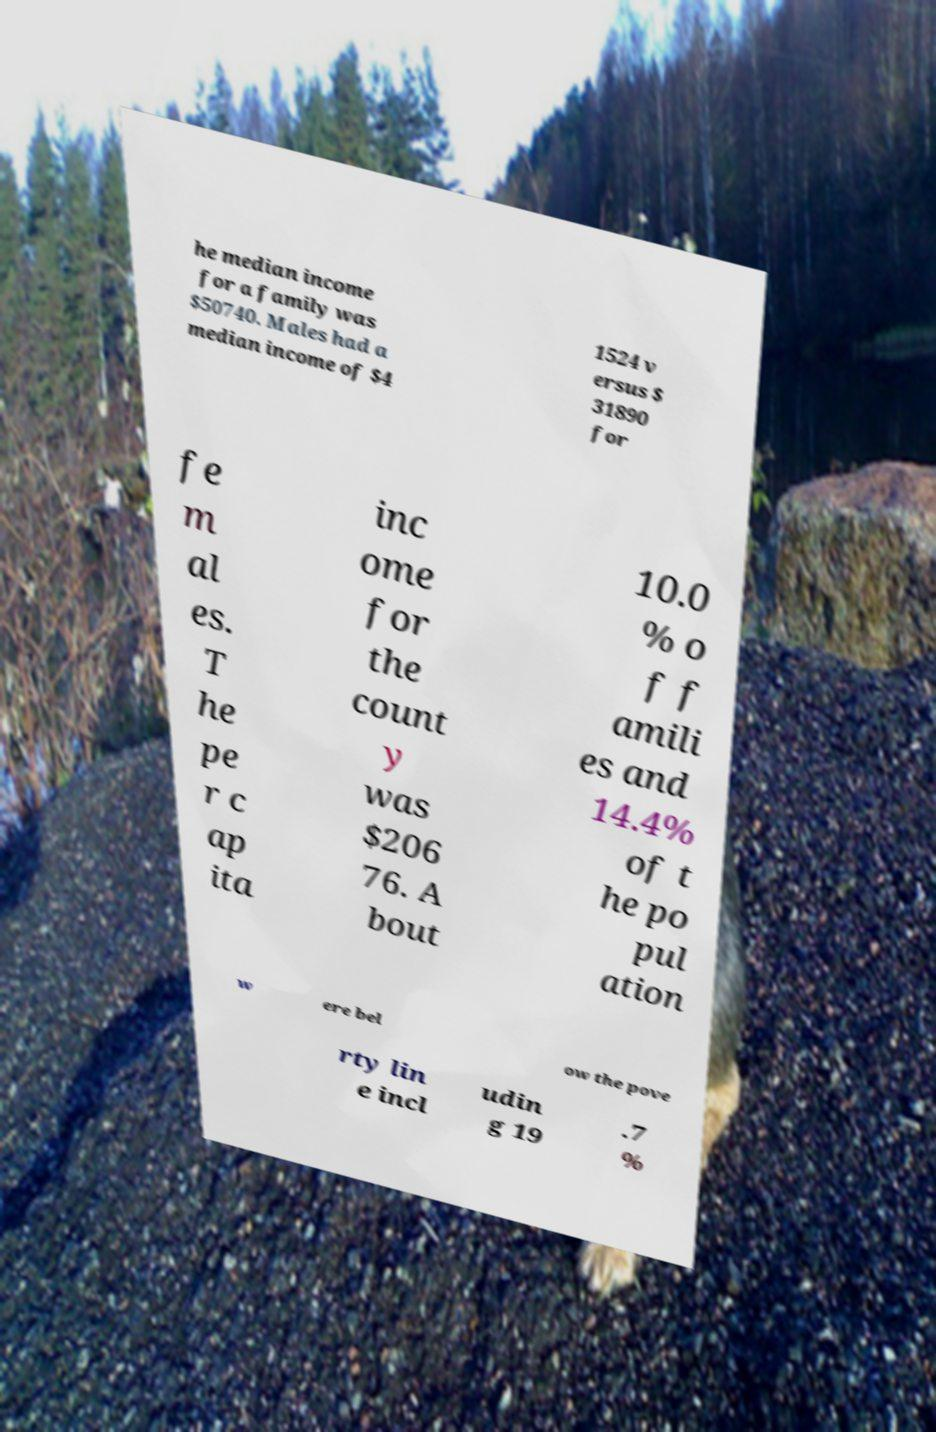Could you assist in decoding the text presented in this image and type it out clearly? he median income for a family was $50740. Males had a median income of $4 1524 v ersus $ 31890 for fe m al es. T he pe r c ap ita inc ome for the count y was $206 76. A bout 10.0 % o f f amili es and 14.4% of t he po pul ation w ere bel ow the pove rty lin e incl udin g 19 .7 % 